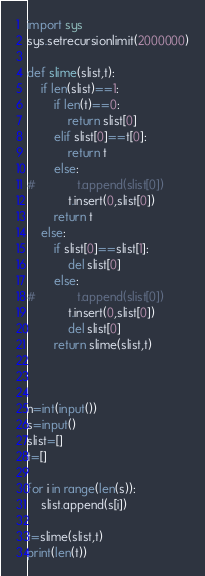<code> <loc_0><loc_0><loc_500><loc_500><_Python_>import sys
sys.setrecursionlimit(2000000)

def slime(slist,t):
    if len(slist)==1:
        if len(t)==0:
            return slist[0]
        elif slist[0]==t[0]:
            return t
        else:
#            t.append(slist[0])
            t.insert(0,slist[0])
        return t
    else:
        if slist[0]==slist[1]:
            del slist[0]
        else:
#            t.append(slist[0])
            t.insert(0,slist[0])
            del slist[0]
        return slime(slist,t)
        


n=int(input())
s=input()
slist=[]
t=[]

for i in range(len(s)):
    slist.append(s[i])
    
t=slime(slist,t)
print(len(t))</code> 